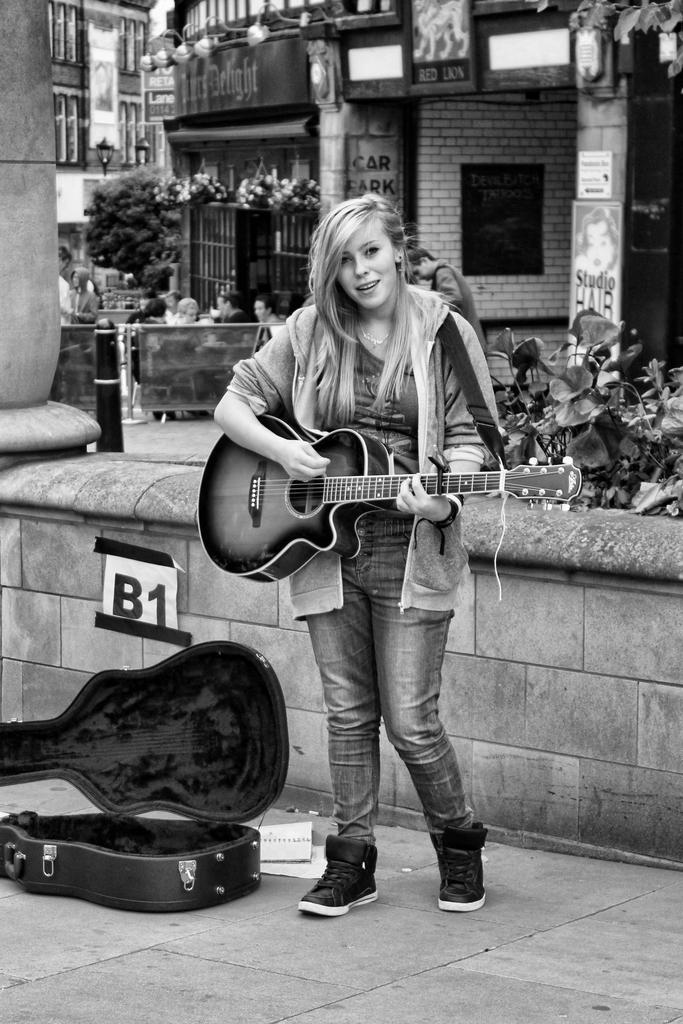Could you give a brief overview of what you see in this image? In this image I see a woman who is standing on the path and she is holding a guitar and smiling, I can also see a bag over here. In the background I see few people, plants and buildings. 